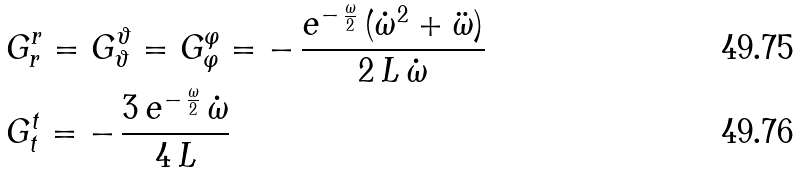Convert formula to latex. <formula><loc_0><loc_0><loc_500><loc_500>& G _ { r } ^ { r } = G _ { \vartheta } ^ { \vartheta } = G _ { \varphi } ^ { \varphi } = - \, \frac { e ^ { - \, \frac { \omega } { 2 } } \, ( { \dot { \omega } } ^ { 2 } + \ddot { \omega } ) } { 2 \, L \, \dot { \omega } } \\ & G _ { t } ^ { t } = - \, \frac { 3 \, e ^ { - \, \frac { \omega } { 2 } } \, \dot { \omega } } { 4 \, L }</formula> 